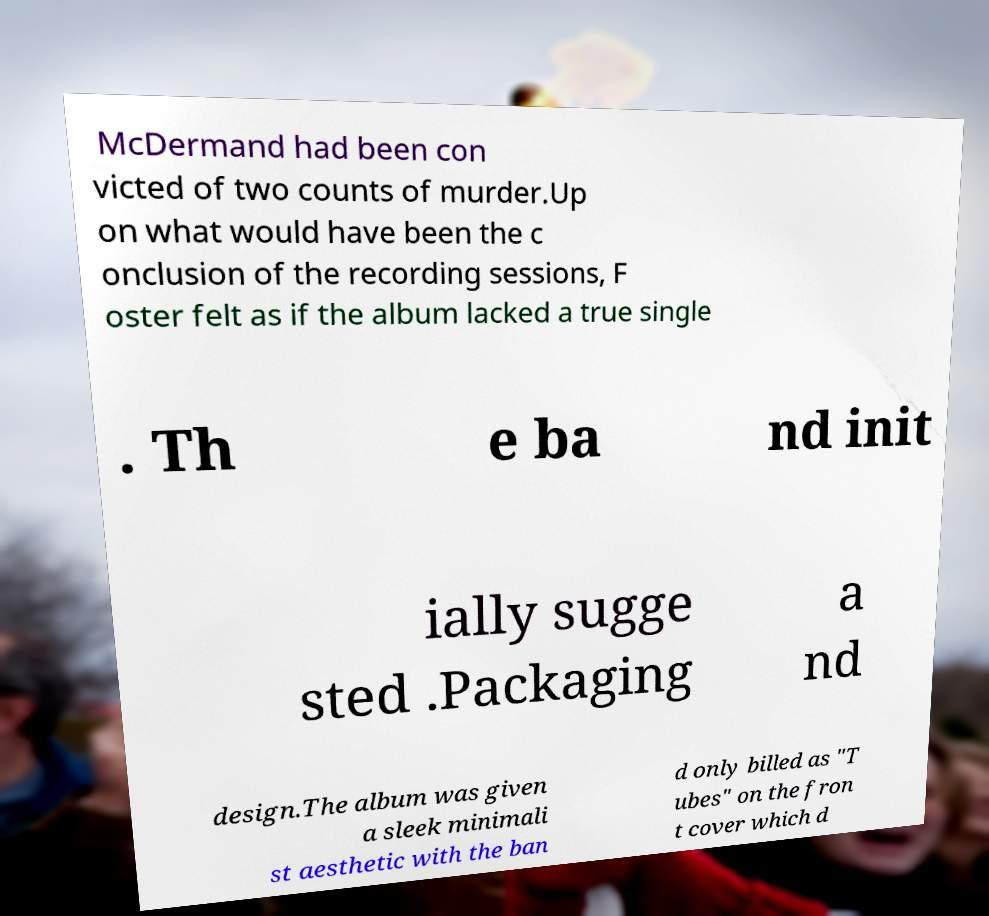Please read and relay the text visible in this image. What does it say? McDermand had been con victed of two counts of murder.Up on what would have been the c onclusion of the recording sessions, F oster felt as if the album lacked a true single . Th e ba nd init ially sugge sted .Packaging a nd design.The album was given a sleek minimali st aesthetic with the ban d only billed as "T ubes" on the fron t cover which d 